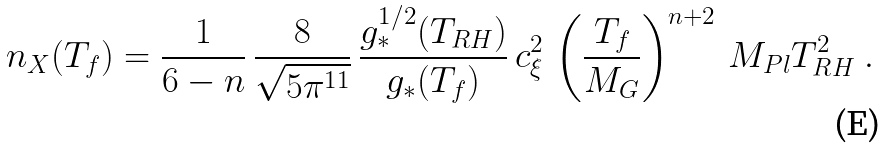Convert formula to latex. <formula><loc_0><loc_0><loc_500><loc_500>n _ { X } ( T _ { f } ) = \frac { 1 } { 6 - n } \, \frac { 8 } { \sqrt { 5 \pi ^ { 1 1 } } } \, \frac { g _ { * } ^ { 1 / 2 } ( T _ { R H } ) } { g _ { * } ( T _ { f } ) } \, c _ { \xi } ^ { 2 } \, \left ( \frac { T _ { f } } { M _ { G } } \right ) ^ { n + 2 } \, M _ { P l } T _ { R H } ^ { 2 } \ .</formula> 